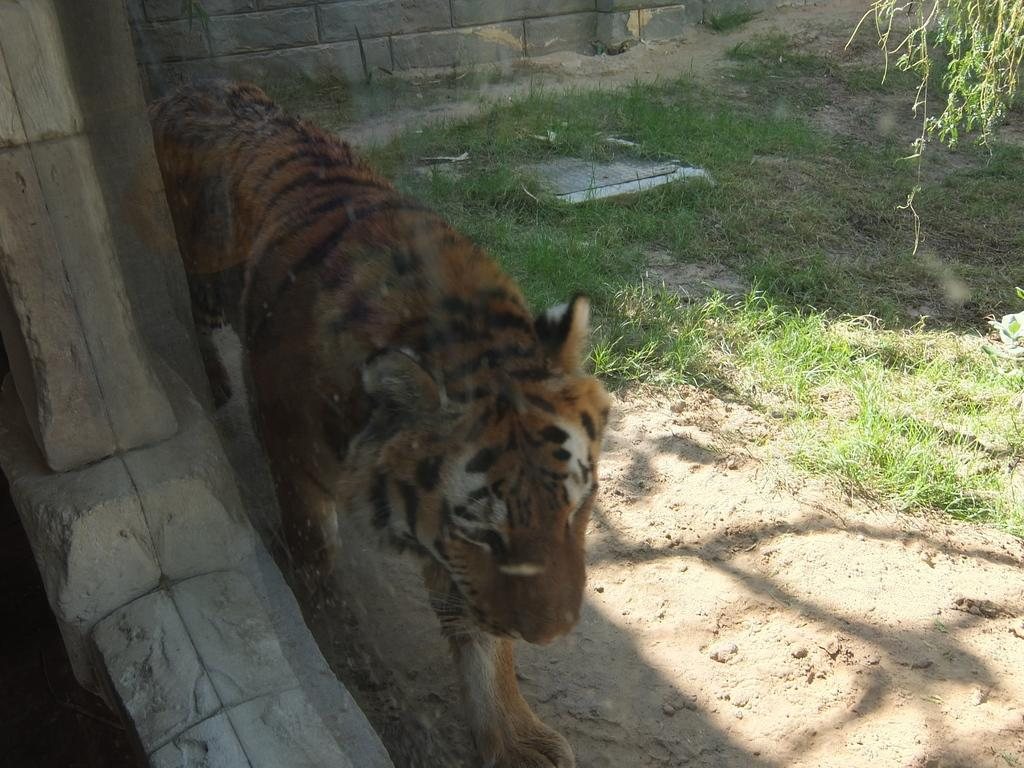What type of animal is in the image? There is a yellow color tiger in the image. What is the ground made of in the image? There is grass on the ground in the image. What structure can be seen in the image? There is a wall visible in the image. What type of gardening tool is being used by the tiger in the image? There is no gardening tool, such as a spade, present in the image. 